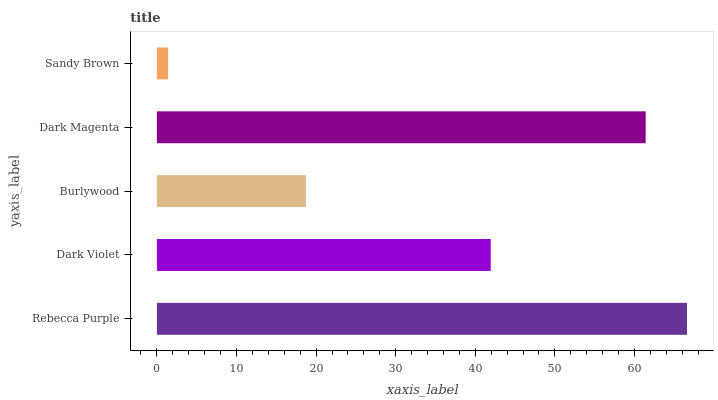Is Sandy Brown the minimum?
Answer yes or no. Yes. Is Rebecca Purple the maximum?
Answer yes or no. Yes. Is Dark Violet the minimum?
Answer yes or no. No. Is Dark Violet the maximum?
Answer yes or no. No. Is Rebecca Purple greater than Dark Violet?
Answer yes or no. Yes. Is Dark Violet less than Rebecca Purple?
Answer yes or no. Yes. Is Dark Violet greater than Rebecca Purple?
Answer yes or no. No. Is Rebecca Purple less than Dark Violet?
Answer yes or no. No. Is Dark Violet the high median?
Answer yes or no. Yes. Is Dark Violet the low median?
Answer yes or no. Yes. Is Burlywood the high median?
Answer yes or no. No. Is Dark Magenta the low median?
Answer yes or no. No. 